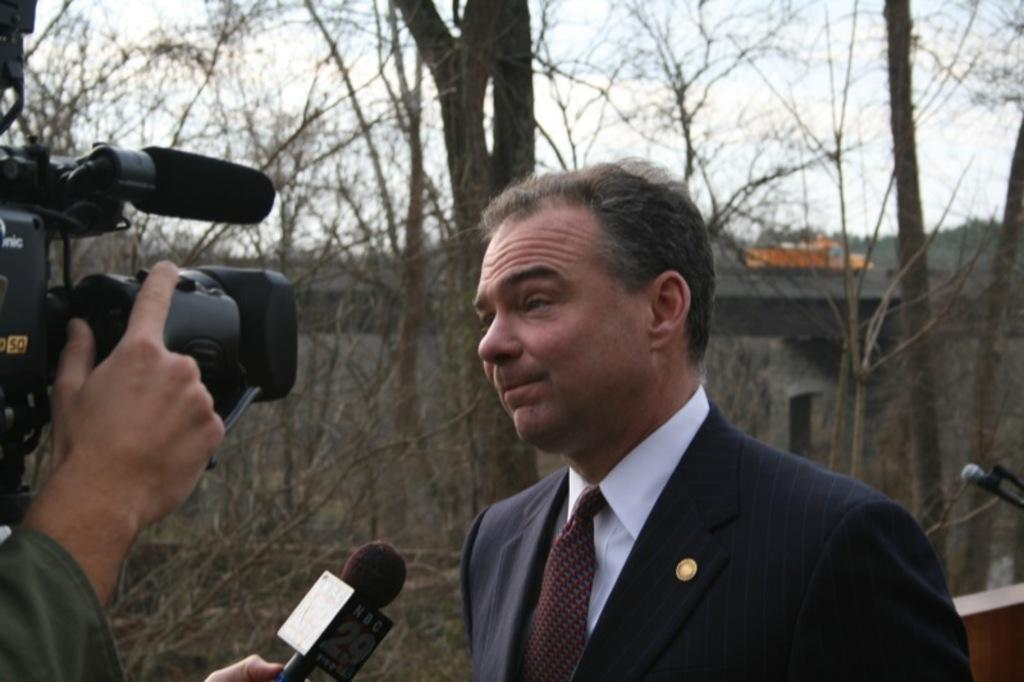What is the main subject of the image? There is a person in the image. What objects can be seen on either side of the person? There is a camera on the left side of the image and a microphone (mike) on the right side of the image. What can be seen in the background of the image? There are trees and clouds in the sky in the background of the image. What type of appliance is being used to write a letter in the image? There is no appliance or letter-writing activity present in the image. What type of wool is visible on the person in the image? There is no wool visible on the person in the image. 